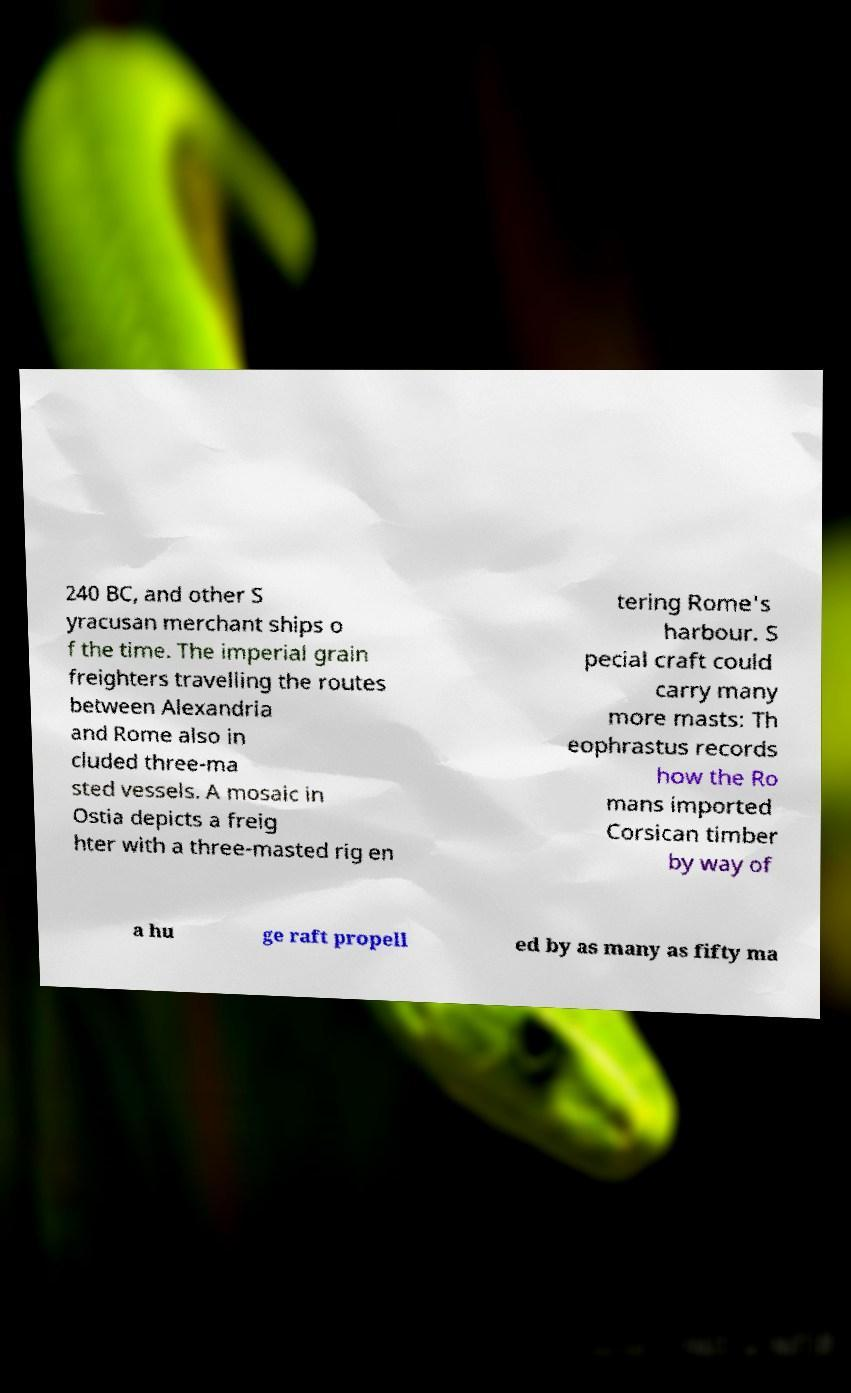Can you accurately transcribe the text from the provided image for me? 240 BC, and other S yracusan merchant ships o f the time. The imperial grain freighters travelling the routes between Alexandria and Rome also in cluded three-ma sted vessels. A mosaic in Ostia depicts a freig hter with a three-masted rig en tering Rome's harbour. S pecial craft could carry many more masts: Th eophrastus records how the Ro mans imported Corsican timber by way of a hu ge raft propell ed by as many as fifty ma 